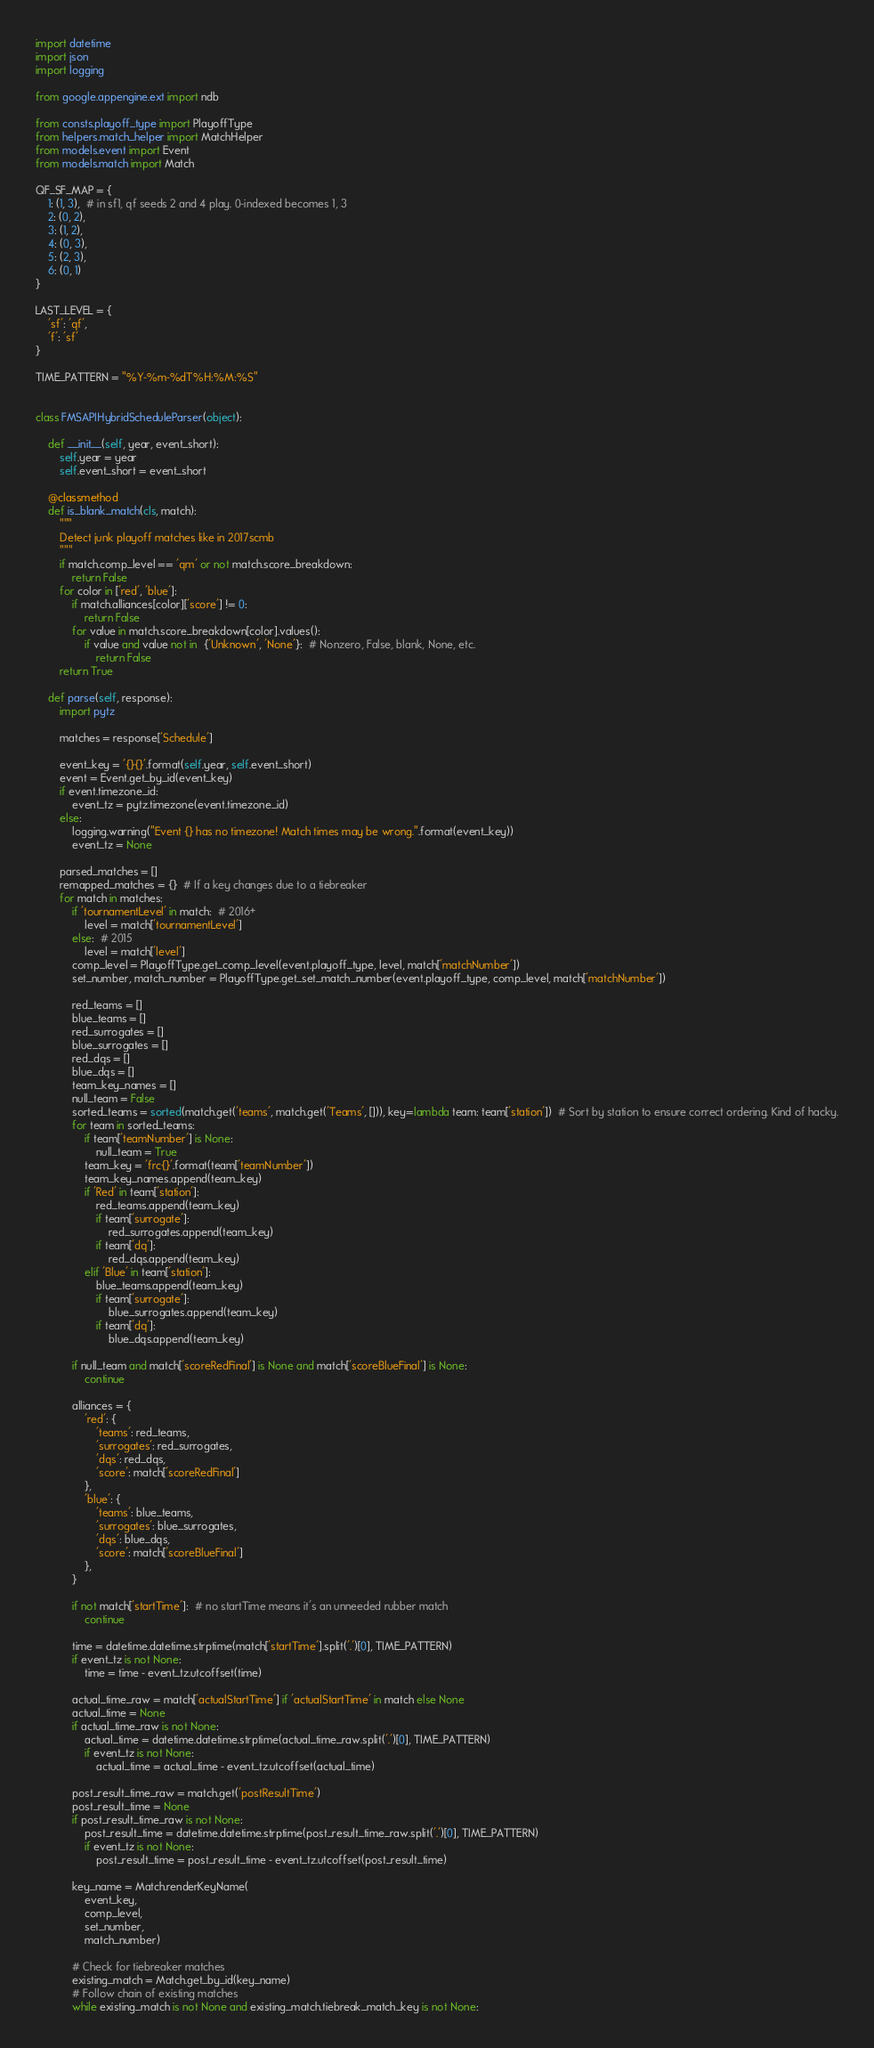<code> <loc_0><loc_0><loc_500><loc_500><_Python_>import datetime
import json
import logging

from google.appengine.ext import ndb

from consts.playoff_type import PlayoffType
from helpers.match_helper import MatchHelper
from models.event import Event
from models.match import Match

QF_SF_MAP = {
    1: (1, 3),  # in sf1, qf seeds 2 and 4 play. 0-indexed becomes 1, 3
    2: (0, 2),
    3: (1, 2),
    4: (0, 3),
    5: (2, 3),
    6: (0, 1)
}

LAST_LEVEL = {
    'sf': 'qf',
    'f': 'sf'
}

TIME_PATTERN = "%Y-%m-%dT%H:%M:%S"


class FMSAPIHybridScheduleParser(object):

    def __init__(self, year, event_short):
        self.year = year
        self.event_short = event_short

    @classmethod
    def is_blank_match(cls, match):
        """
        Detect junk playoff matches like in 2017scmb
        """
        if match.comp_level == 'qm' or not match.score_breakdown:
            return False
        for color in ['red', 'blue']:
            if match.alliances[color]['score'] != 0:
                return False
            for value in match.score_breakdown[color].values():
                if value and value not in  {'Unknown', 'None'}:  # Nonzero, False, blank, None, etc.
                    return False
        return True

    def parse(self, response):
        import pytz

        matches = response['Schedule']

        event_key = '{}{}'.format(self.year, self.event_short)
        event = Event.get_by_id(event_key)
        if event.timezone_id:
            event_tz = pytz.timezone(event.timezone_id)
        else:
            logging.warning("Event {} has no timezone! Match times may be wrong.".format(event_key))
            event_tz = None

        parsed_matches = []
        remapped_matches = {}  # If a key changes due to a tiebreaker
        for match in matches:
            if 'tournamentLevel' in match:  # 2016+
                level = match['tournamentLevel']
            else:  # 2015
                level = match['level']
            comp_level = PlayoffType.get_comp_level(event.playoff_type, level, match['matchNumber'])
            set_number, match_number = PlayoffType.get_set_match_number(event.playoff_type, comp_level, match['matchNumber'])

            red_teams = []
            blue_teams = []
            red_surrogates = []
            blue_surrogates = []
            red_dqs = []
            blue_dqs = []
            team_key_names = []
            null_team = False
            sorted_teams = sorted(match.get('teams', match.get('Teams', [])), key=lambda team: team['station'])  # Sort by station to ensure correct ordering. Kind of hacky.
            for team in sorted_teams:
                if team['teamNumber'] is None:
                    null_team = True
                team_key = 'frc{}'.format(team['teamNumber'])
                team_key_names.append(team_key)
                if 'Red' in team['station']:
                    red_teams.append(team_key)
                    if team['surrogate']:
                        red_surrogates.append(team_key)
                    if team['dq']:
                        red_dqs.append(team_key)
                elif 'Blue' in team['station']:
                    blue_teams.append(team_key)
                    if team['surrogate']:
                        blue_surrogates.append(team_key)
                    if team['dq']:
                        blue_dqs.append(team_key)

            if null_team and match['scoreRedFinal'] is None and match['scoreBlueFinal'] is None:
                continue

            alliances = {
                'red': {
                    'teams': red_teams,
                    'surrogates': red_surrogates,
                    'dqs': red_dqs,
                    'score': match['scoreRedFinal']
                },
                'blue': {
                    'teams': blue_teams,
                    'surrogates': blue_surrogates,
                    'dqs': blue_dqs,
                    'score': match['scoreBlueFinal']
                },
            }

            if not match['startTime']:  # no startTime means it's an unneeded rubber match
                continue

            time = datetime.datetime.strptime(match['startTime'].split('.')[0], TIME_PATTERN)
            if event_tz is not None:
                time = time - event_tz.utcoffset(time)

            actual_time_raw = match['actualStartTime'] if 'actualStartTime' in match else None
            actual_time = None
            if actual_time_raw is not None:
                actual_time = datetime.datetime.strptime(actual_time_raw.split('.')[0], TIME_PATTERN)
                if event_tz is not None:
                    actual_time = actual_time - event_tz.utcoffset(actual_time)

            post_result_time_raw = match.get('postResultTime')
            post_result_time = None
            if post_result_time_raw is not None:
                post_result_time = datetime.datetime.strptime(post_result_time_raw.split('.')[0], TIME_PATTERN)
                if event_tz is not None:
                    post_result_time = post_result_time - event_tz.utcoffset(post_result_time)

            key_name = Match.renderKeyName(
                event_key,
                comp_level,
                set_number,
                match_number)

            # Check for tiebreaker matches
            existing_match = Match.get_by_id(key_name)
            # Follow chain of existing matches
            while existing_match is not None and existing_match.tiebreak_match_key is not None:</code> 